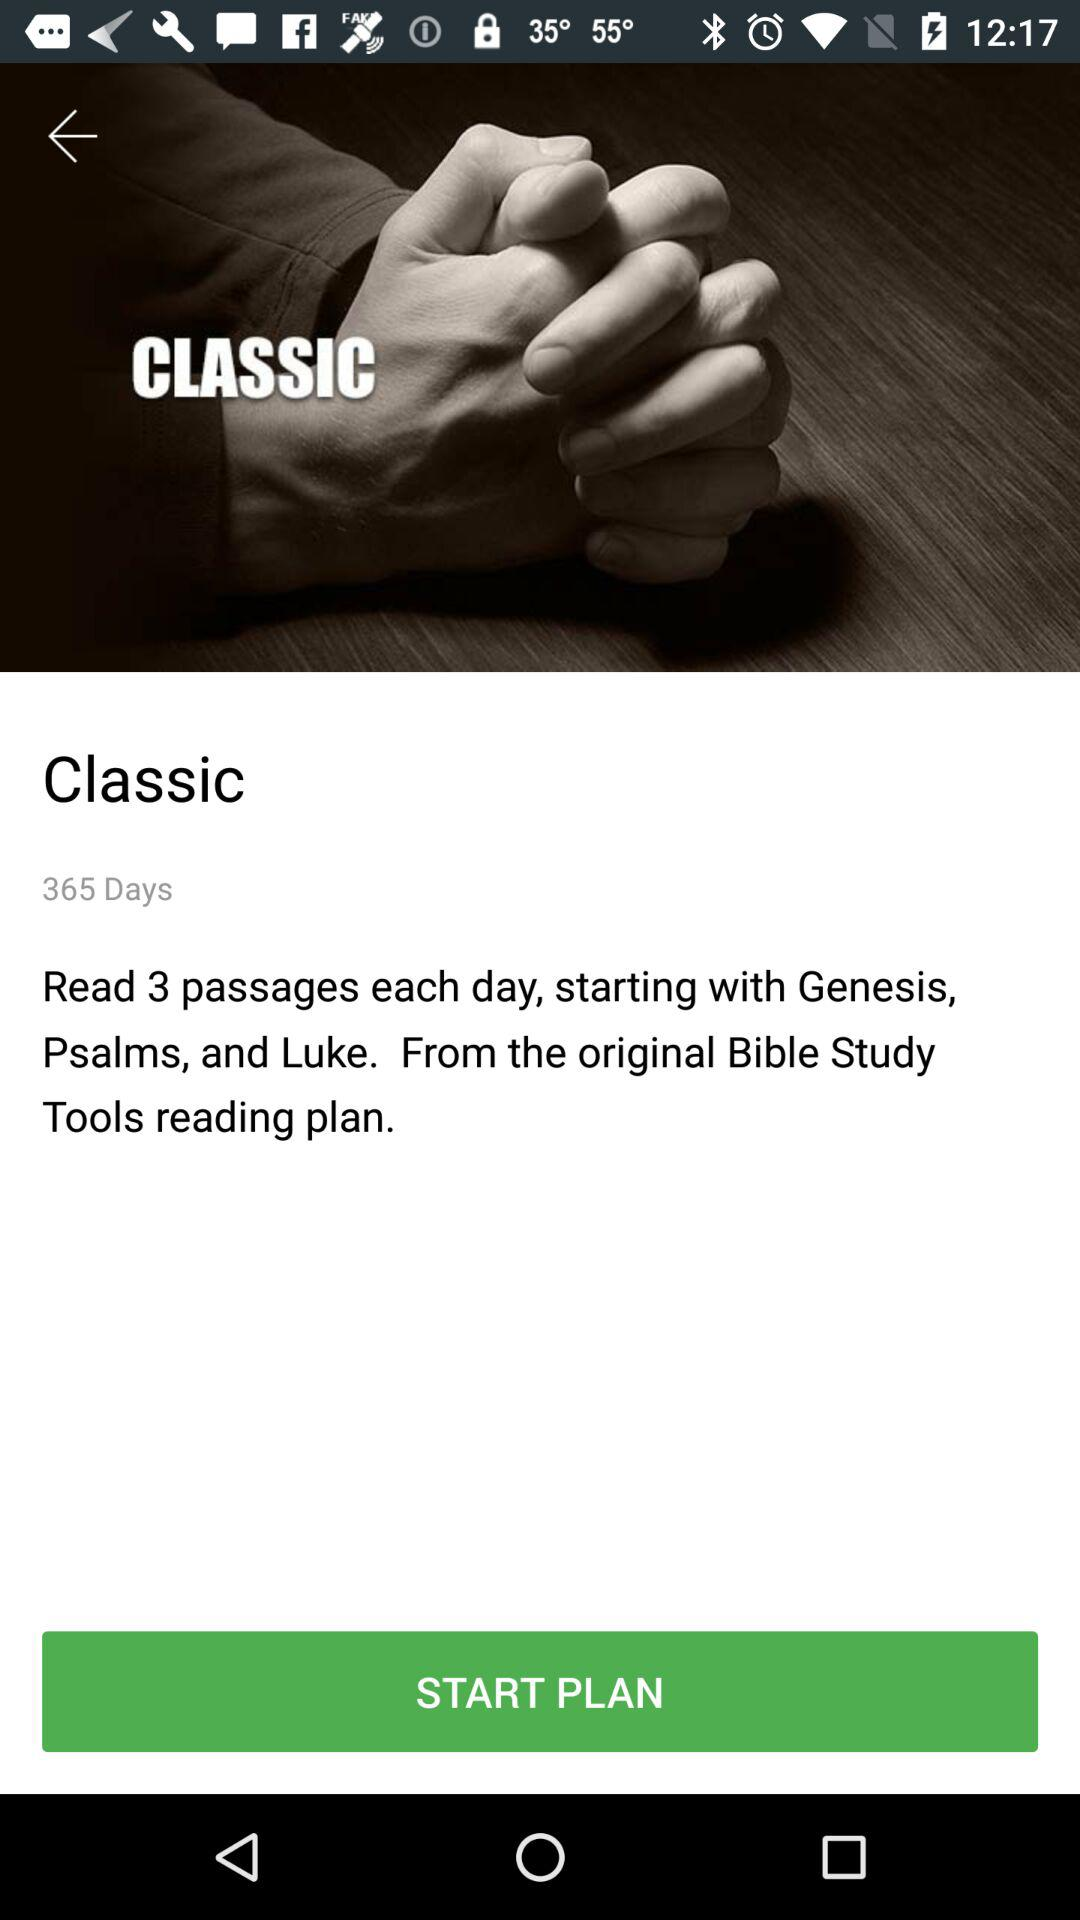How many days are shown on the screen? There are 365 days. 